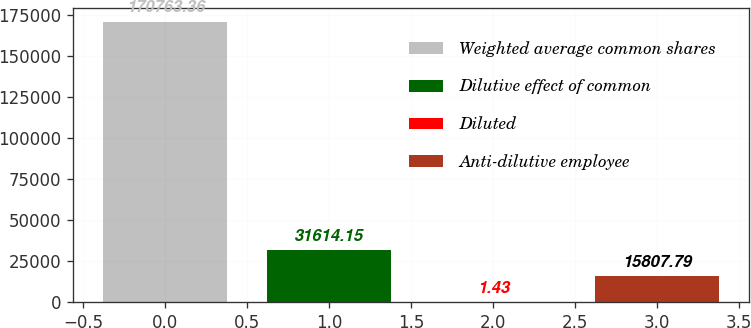Convert chart. <chart><loc_0><loc_0><loc_500><loc_500><bar_chart><fcel>Weighted average common shares<fcel>Dilutive effect of common<fcel>Diluted<fcel>Anti-dilutive employee<nl><fcel>170763<fcel>31614.2<fcel>1.43<fcel>15807.8<nl></chart> 